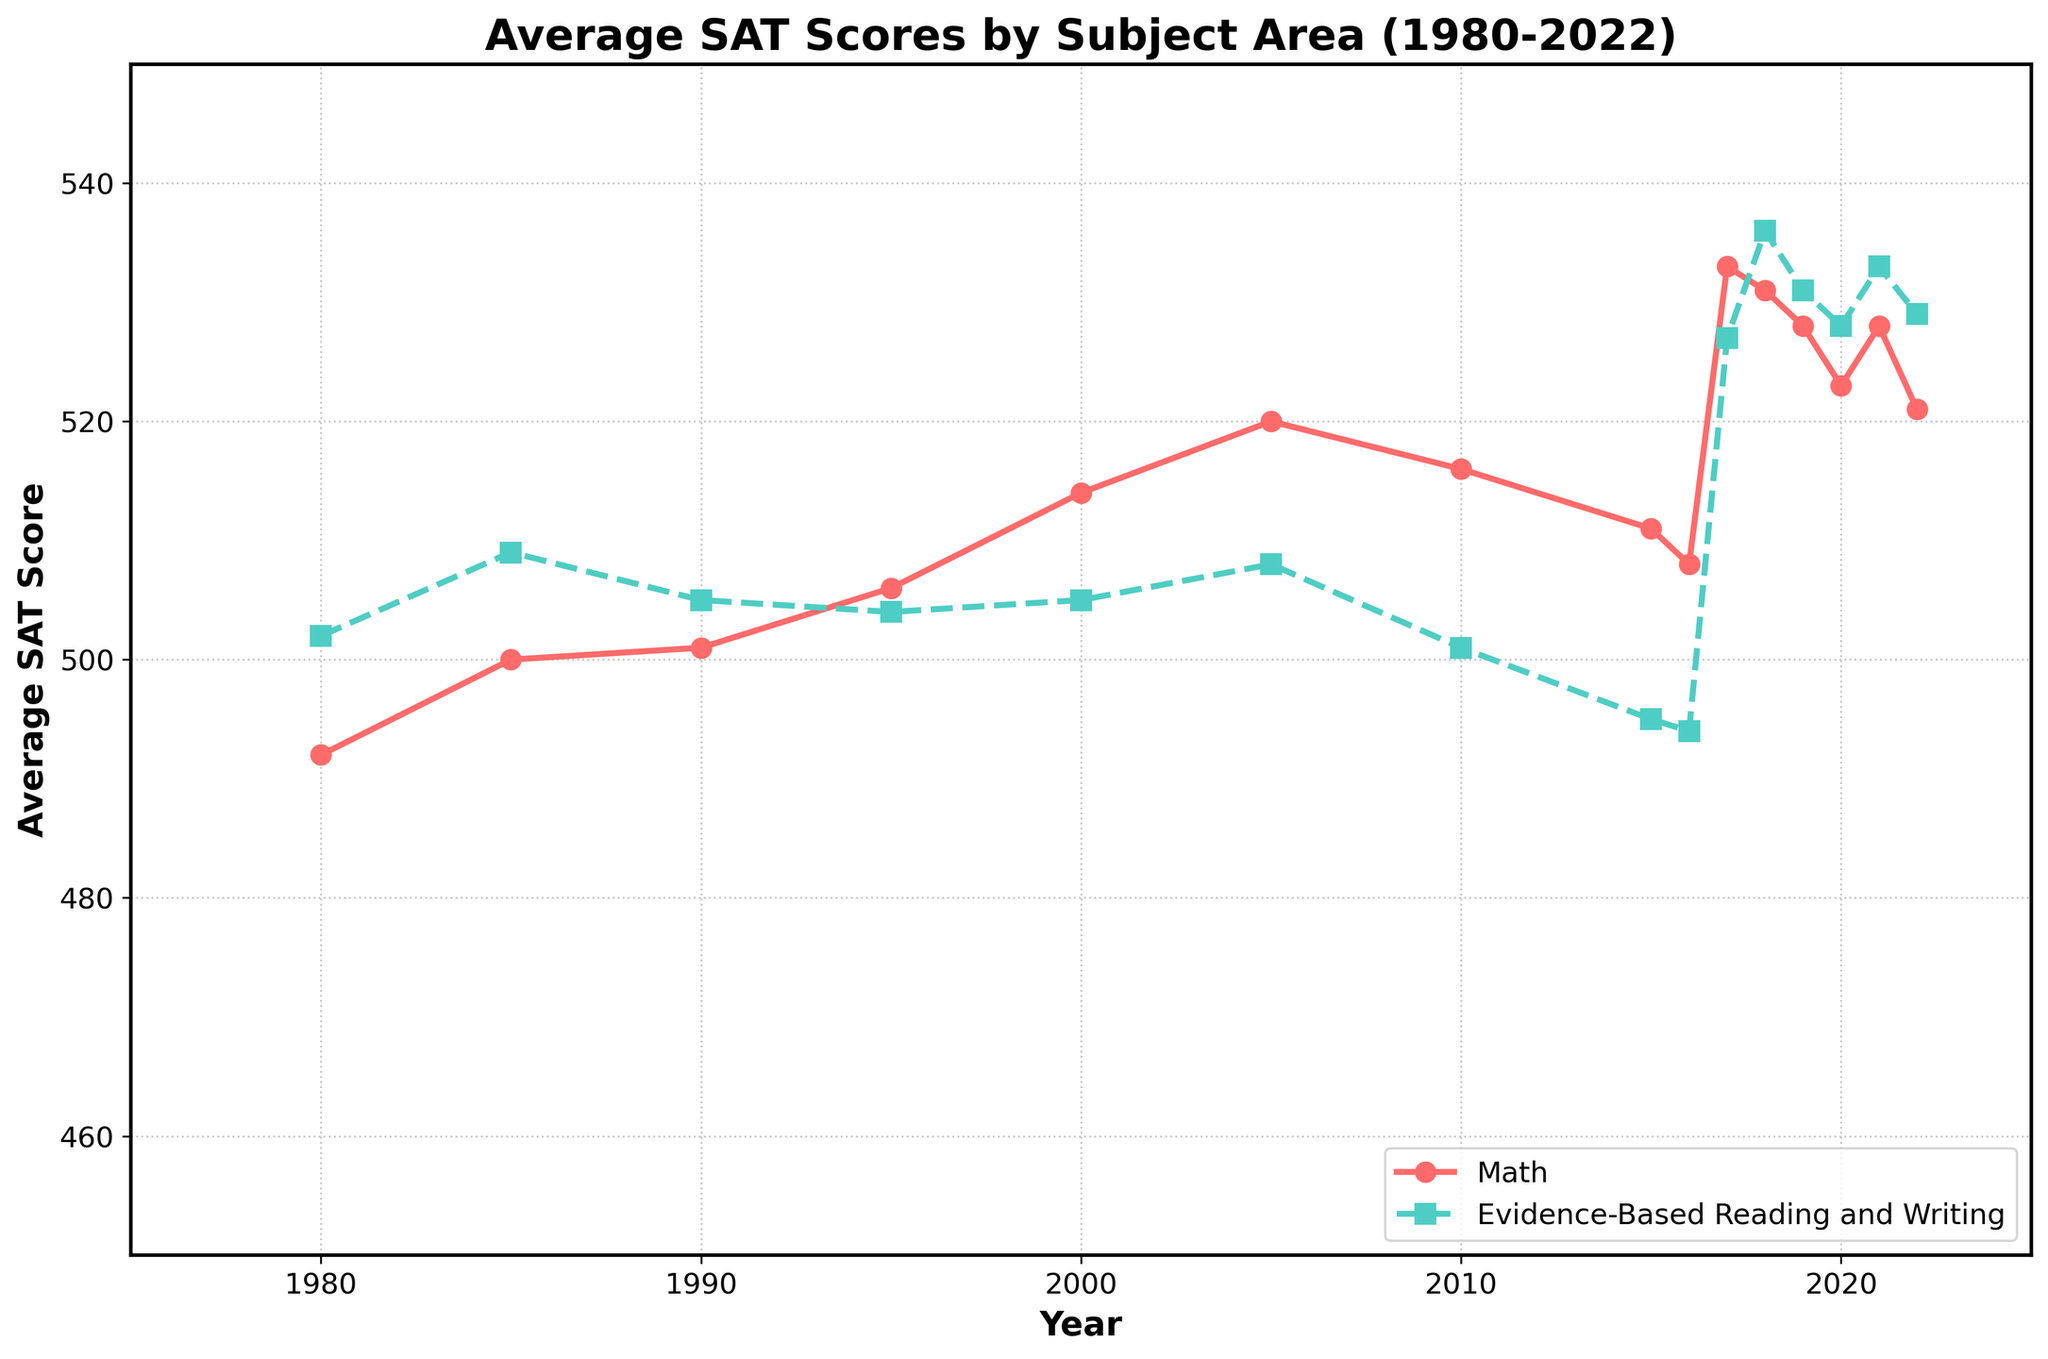What year had the highest average Math score, and what was the score? First, locate the highest point on the Math line. This occurs in 2017, where the Math score peaks at 533.
Answer: 2017, 533 Compare the Math and Reading scores in 2010. Which subject had a higher score and by how much? Find the scores for both subjects in 2010. Math had a score of 516, while Reading had a score of 501. Subtract the Reading score from the Math score: 516 - 501 = 15.
Answer: Math, 15 What is the average Math score between 1980 and 2022? Sum all Math scores and divide by the number of data points: (492 + 500 + 501 + 506 + 514 + 520 + 516 + 511 + 508 + 533 + 531 + 528 + 523 + 528 + 521) / 15 = 514.4
Answer: 514.4 In which year did the Evidence-Based Reading and Writing score see the most significant increase from the previous year? Observe the changes in Reading scores year-by-year. The largest jump is from 2016 to 2017, increasing from 494 to 527, a change of 33 points.
Answer: 2017 By how much did the Math score in 2022 differ from the score in 1980, and was it an increase or a decrease? Subtract the 1980 score from the 2022 score: 521 - 492 = 29. Since the result is positive, it is an increase.
Answer: 29, increase During which decade did the Math score see the most stable values, and what was the range of scores in that decade? Look for the decade with the smallest range of Math scores. From 1980 to 1989, the values ranged from 492 to 501, a range of 9 points.
Answer: 1980s, 9 points Identify the year with the smallest gap between Math and Reading scores and state the gap. Check the difference between scores year by year. In 1990, the scores were Math: 501, Reading: 505. The gap is 4 points.
Answer: 1990, 4 points How many total data points are represented in the chart for each subject? Count the number of years. Both subjects have data points for each of the 15 years listed.
Answer: 15 